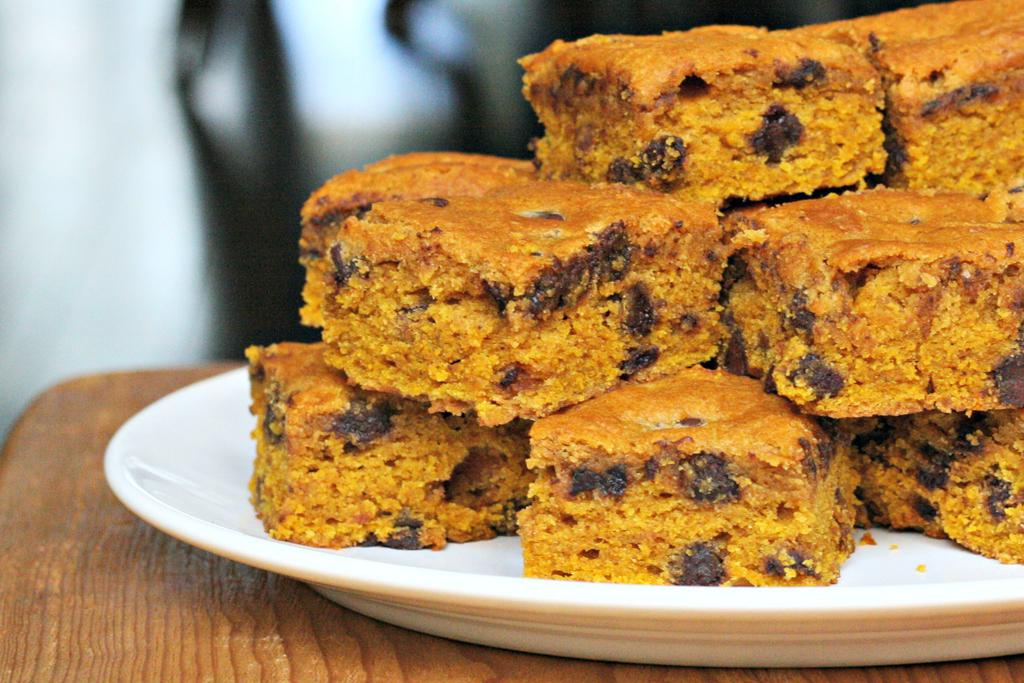What type of food can be seen in the image? There are cake pieces in the image. Where are the cake pieces located? The cake pieces are in a plate. On what surface is the plate with cake pieces placed? The plate with cake pieces is placed on a table. What type of board is used to make the payment for the cake in the image? There is no board or payment mentioned in the image; it only shows cake pieces in a plate on a table. 